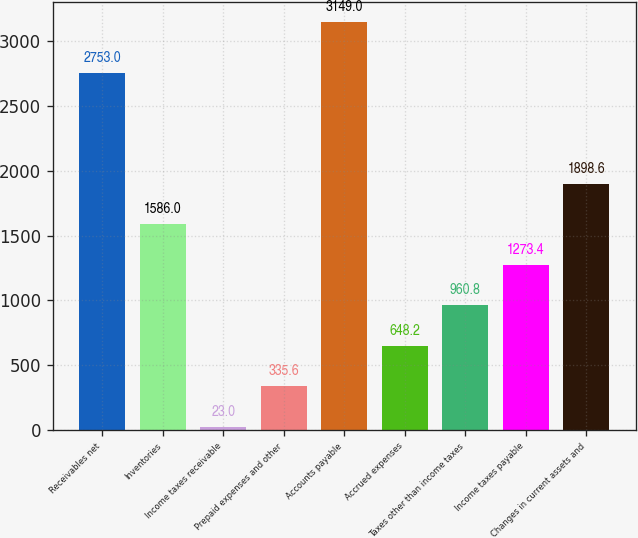Convert chart. <chart><loc_0><loc_0><loc_500><loc_500><bar_chart><fcel>Receivables net<fcel>Inventories<fcel>Income taxes receivable<fcel>Prepaid expenses and other<fcel>Accounts payable<fcel>Accrued expenses<fcel>Taxes other than income taxes<fcel>Income taxes payable<fcel>Changes in current assets and<nl><fcel>2753<fcel>1586<fcel>23<fcel>335.6<fcel>3149<fcel>648.2<fcel>960.8<fcel>1273.4<fcel>1898.6<nl></chart> 